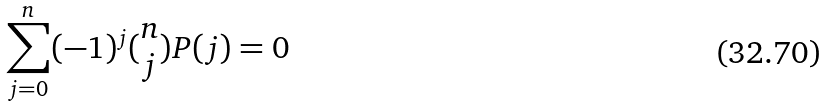Convert formula to latex. <formula><loc_0><loc_0><loc_500><loc_500>\sum _ { j = 0 } ^ { n } ( - 1 ) ^ { j } ( \begin{matrix} n \\ j \end{matrix} ) P ( j ) = 0</formula> 